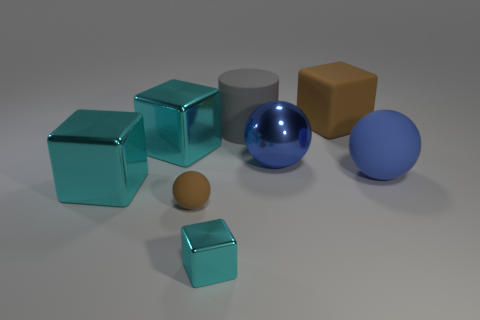There is a rubber object that is the same color as the rubber block; what shape is it?
Keep it short and to the point. Sphere. The matte sphere that is the same color as the large metallic ball is what size?
Ensure brevity in your answer.  Large. The big object that is in front of the blue object right of the large brown matte object is what color?
Give a very brief answer. Cyan. Do the brown rubber block and the brown rubber sphere have the same size?
Keep it short and to the point. No. What number of balls are either large matte things or large gray objects?
Keep it short and to the point. 1. What number of big blue spheres are to the right of the large object behind the gray cylinder?
Offer a terse response. 1. Does the big gray thing have the same shape as the tiny cyan shiny object?
Your response must be concise. No. What is the size of the other blue thing that is the same shape as the blue rubber thing?
Offer a terse response. Large. The large blue thing on the left side of the brown matte object to the right of the big gray thing is what shape?
Your response must be concise. Sphere. What is the size of the gray matte cylinder?
Your answer should be very brief. Large. 